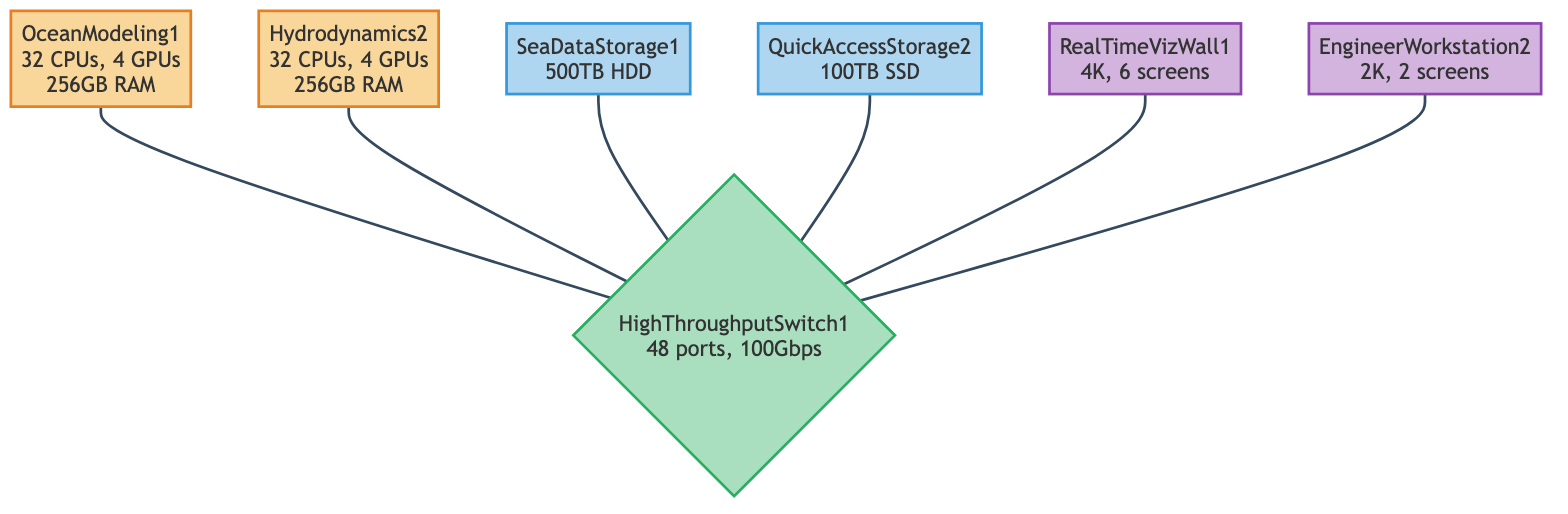What are the names of the compute nodes? The compute nodes in the diagram are specifically named OceanModeling1 and Hydrodynamics2. They are distinctly labeled in the diagram as compute nodes, making identification straightforward.
Answer: OceanModeling1, Hydrodynamics2 How many GPUs does each compute node have? Each compute node, OceanModeling1 and Hydrodynamics2, has 4 GPUs associated with them. This information is stated right next to each compute node in the diagram.
Answer: 4 What is the storage capacity of SeaDataStorage1? SeaDataStorage1 has a capacity of 500TB. This value is listed explicitly under the node for SeaDataStorage1, making it easy to obtain.
Answer: 500TB Which visualization unit has the highest maximum resolution? RealTimeVizWall1 has a maximum resolution of 4K, which is the highest resolution among the visualization units. The resolutions stated in the diagram allow for direct comparison.
Answer: 4K How many ports does the network switch have? The network switch, HighThroughputSwitch1, has 48 ports. This specification is clearly marked in the diagram next to the switch node.
Answer: 48 Which compute node connects to the storage systems? Both compute nodes, OceanModeling1 and Hydrodynamics2, connect to the network switch, which in turn connects to the storage systems, indicating their connectivity to the storage.
Answer: OceanModeling1, Hydrodynamics2 What type of storage does QuickAccessStorage2 use? QuickAccessStorage2 is an SSD type storage system, as labeled in the diagram. The type of each storage system is explicitly stated next to them.
Answer: SSD Which elements are connected to the HighThroughputSwitch1? All compute nodes, storage systems, and visualization units are connected to the HighThroughputSwitch1, indicated by direct connections from each element to the switch in the diagram.
Answer: OceanModeling1, Hydrodynamics2, SeaDataStorage1, QuickAccessStorage2, RealTimeVizWall1, EngineerWorkstation2 What is the speed of the network switch? HighThroughputSwitch1 operates at a speed of 100Gbps, as mentioned next to the switch in the diagram. This speed is crucial for network performance.
Answer: 100Gbps 